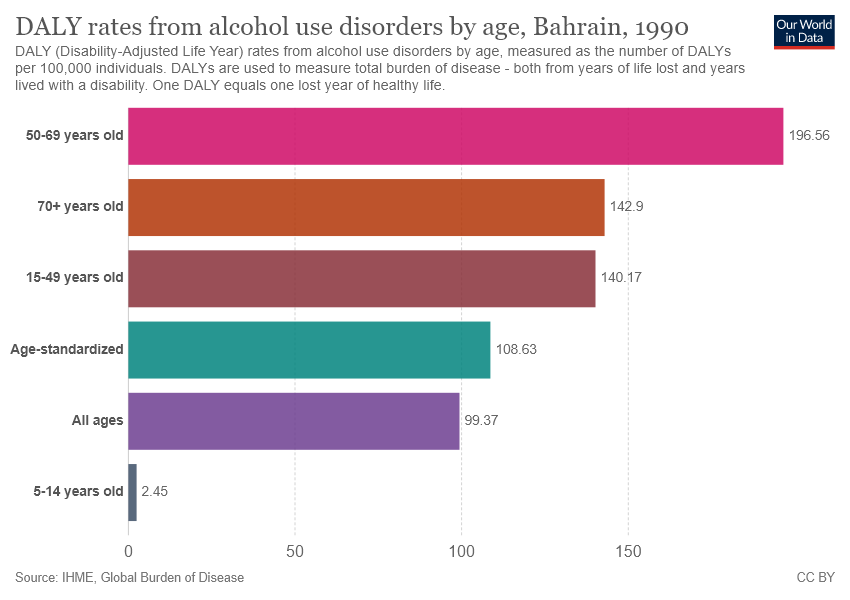Identify some key points in this picture. According to recent studies, alcohol use disorder is most prevalent among individuals aged 26-30, with a pink color representing the highest rate of alcohol use disorder among that age group. The value of "All ages" is not more than age-standardized. 